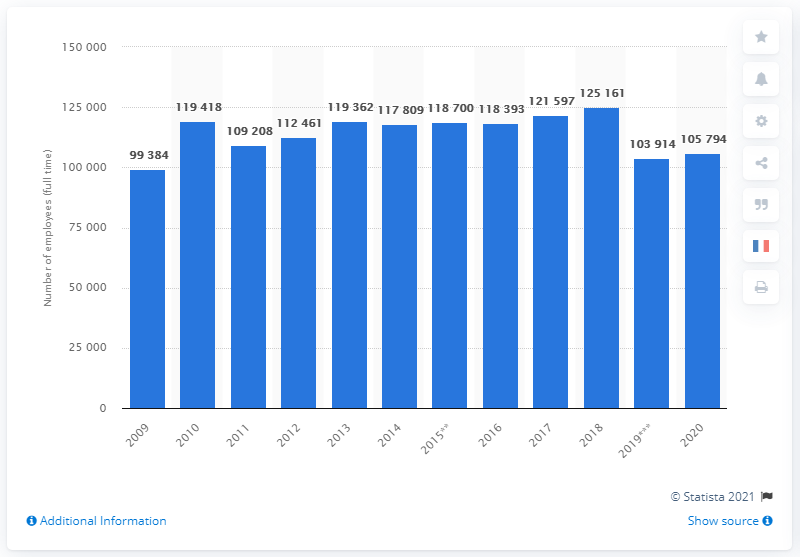Mention a couple of crucial points in this snapshot. In the year 2020, Novartis experienced its largest number of employees in recent history. 